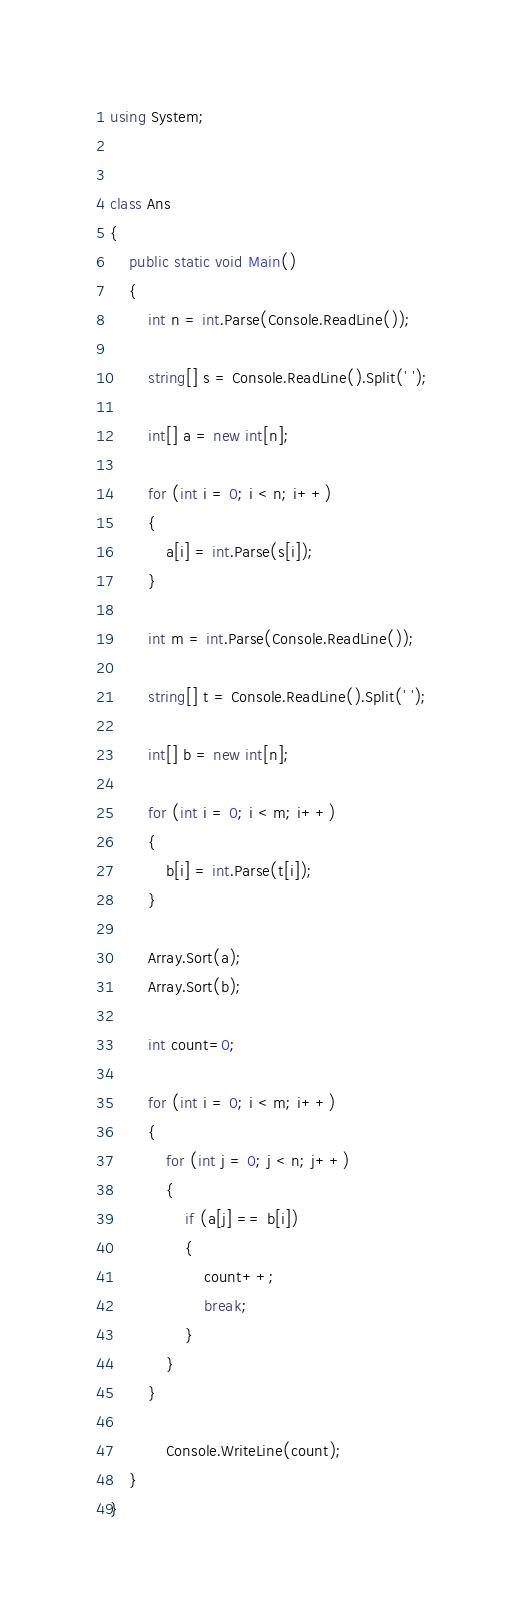Convert code to text. <code><loc_0><loc_0><loc_500><loc_500><_C#_>using System;


class Ans
{
    public static void Main()
    {
        int n = int.Parse(Console.ReadLine());

        string[] s = Console.ReadLine().Split(' ');

        int[] a = new int[n];

        for (int i = 0; i < n; i++)
        {
            a[i] = int.Parse(s[i]);
        }

        int m = int.Parse(Console.ReadLine());

        string[] t = Console.ReadLine().Split(' ');

        int[] b = new int[n];

        for (int i = 0; i < m; i++)
        {
            b[i] = int.Parse(t[i]);
        }

        Array.Sort(a);
        Array.Sort(b);

        int count=0;

        for (int i = 0; i < m; i++)
        {
            for (int j = 0; j < n; j++)
            {
                if (a[j] == b[i])
                {
                    count++;
                    break;
                }
            }
        }

            Console.WriteLine(count);
    }
}</code> 